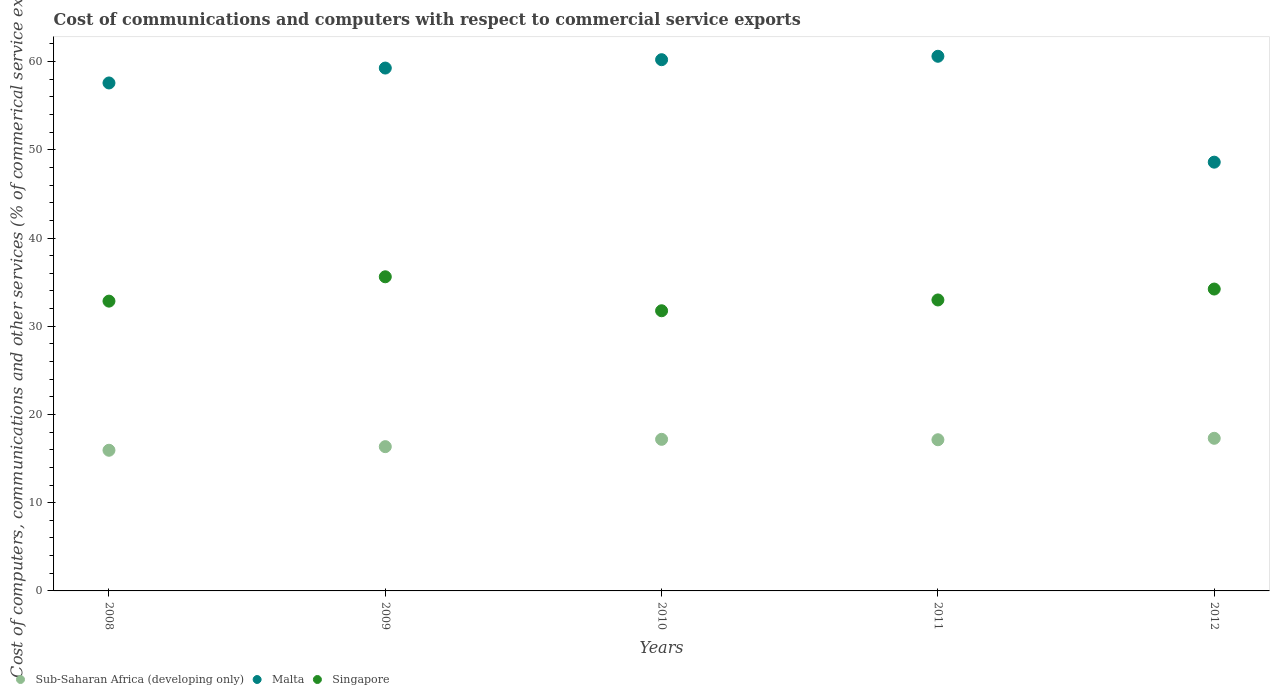What is the cost of communications and computers in Malta in 2010?
Your answer should be very brief. 60.22. Across all years, what is the maximum cost of communications and computers in Singapore?
Give a very brief answer. 35.61. Across all years, what is the minimum cost of communications and computers in Singapore?
Keep it short and to the point. 31.76. In which year was the cost of communications and computers in Malta minimum?
Give a very brief answer. 2012. What is the total cost of communications and computers in Sub-Saharan Africa (developing only) in the graph?
Ensure brevity in your answer.  83.92. What is the difference between the cost of communications and computers in Sub-Saharan Africa (developing only) in 2011 and that in 2012?
Provide a succinct answer. -0.16. What is the difference between the cost of communications and computers in Malta in 2011 and the cost of communications and computers in Singapore in 2009?
Give a very brief answer. 25. What is the average cost of communications and computers in Sub-Saharan Africa (developing only) per year?
Make the answer very short. 16.78. In the year 2012, what is the difference between the cost of communications and computers in Sub-Saharan Africa (developing only) and cost of communications and computers in Singapore?
Offer a very short reply. -16.92. What is the ratio of the cost of communications and computers in Malta in 2009 to that in 2012?
Your answer should be very brief. 1.22. Is the difference between the cost of communications and computers in Sub-Saharan Africa (developing only) in 2009 and 2011 greater than the difference between the cost of communications and computers in Singapore in 2009 and 2011?
Your answer should be compact. No. What is the difference between the highest and the second highest cost of communications and computers in Singapore?
Your response must be concise. 1.39. What is the difference between the highest and the lowest cost of communications and computers in Sub-Saharan Africa (developing only)?
Offer a terse response. 1.36. In how many years, is the cost of communications and computers in Singapore greater than the average cost of communications and computers in Singapore taken over all years?
Ensure brevity in your answer.  2. Does the cost of communications and computers in Singapore monotonically increase over the years?
Give a very brief answer. No. Is the cost of communications and computers in Singapore strictly less than the cost of communications and computers in Sub-Saharan Africa (developing only) over the years?
Your answer should be compact. No. How many dotlines are there?
Provide a succinct answer. 3. How many years are there in the graph?
Your answer should be very brief. 5. How many legend labels are there?
Provide a short and direct response. 3. What is the title of the graph?
Offer a terse response. Cost of communications and computers with respect to commercial service exports. Does "Bahamas" appear as one of the legend labels in the graph?
Your answer should be very brief. No. What is the label or title of the X-axis?
Give a very brief answer. Years. What is the label or title of the Y-axis?
Your answer should be very brief. Cost of computers, communications and other services (% of commerical service exports). What is the Cost of computers, communications and other services (% of commerical service exports) in Sub-Saharan Africa (developing only) in 2008?
Offer a very short reply. 15.95. What is the Cost of computers, communications and other services (% of commerical service exports) of Malta in 2008?
Provide a short and direct response. 57.58. What is the Cost of computers, communications and other services (% of commerical service exports) in Singapore in 2008?
Provide a succinct answer. 32.85. What is the Cost of computers, communications and other services (% of commerical service exports) in Sub-Saharan Africa (developing only) in 2009?
Provide a succinct answer. 16.35. What is the Cost of computers, communications and other services (% of commerical service exports) in Malta in 2009?
Provide a succinct answer. 59.27. What is the Cost of computers, communications and other services (% of commerical service exports) of Singapore in 2009?
Your answer should be compact. 35.61. What is the Cost of computers, communications and other services (% of commerical service exports) in Sub-Saharan Africa (developing only) in 2010?
Ensure brevity in your answer.  17.18. What is the Cost of computers, communications and other services (% of commerical service exports) of Malta in 2010?
Your response must be concise. 60.22. What is the Cost of computers, communications and other services (% of commerical service exports) in Singapore in 2010?
Your answer should be very brief. 31.76. What is the Cost of computers, communications and other services (% of commerical service exports) in Sub-Saharan Africa (developing only) in 2011?
Give a very brief answer. 17.14. What is the Cost of computers, communications and other services (% of commerical service exports) of Malta in 2011?
Your answer should be compact. 60.61. What is the Cost of computers, communications and other services (% of commerical service exports) in Singapore in 2011?
Your answer should be very brief. 32.98. What is the Cost of computers, communications and other services (% of commerical service exports) in Sub-Saharan Africa (developing only) in 2012?
Provide a short and direct response. 17.3. What is the Cost of computers, communications and other services (% of commerical service exports) of Malta in 2012?
Ensure brevity in your answer.  48.6. What is the Cost of computers, communications and other services (% of commerical service exports) in Singapore in 2012?
Your answer should be compact. 34.22. Across all years, what is the maximum Cost of computers, communications and other services (% of commerical service exports) of Sub-Saharan Africa (developing only)?
Give a very brief answer. 17.3. Across all years, what is the maximum Cost of computers, communications and other services (% of commerical service exports) in Malta?
Your answer should be compact. 60.61. Across all years, what is the maximum Cost of computers, communications and other services (% of commerical service exports) in Singapore?
Make the answer very short. 35.61. Across all years, what is the minimum Cost of computers, communications and other services (% of commerical service exports) of Sub-Saharan Africa (developing only)?
Give a very brief answer. 15.95. Across all years, what is the minimum Cost of computers, communications and other services (% of commerical service exports) in Malta?
Offer a very short reply. 48.6. Across all years, what is the minimum Cost of computers, communications and other services (% of commerical service exports) of Singapore?
Keep it short and to the point. 31.76. What is the total Cost of computers, communications and other services (% of commerical service exports) in Sub-Saharan Africa (developing only) in the graph?
Offer a very short reply. 83.92. What is the total Cost of computers, communications and other services (% of commerical service exports) in Malta in the graph?
Provide a short and direct response. 286.29. What is the total Cost of computers, communications and other services (% of commerical service exports) in Singapore in the graph?
Your response must be concise. 167.43. What is the difference between the Cost of computers, communications and other services (% of commerical service exports) of Sub-Saharan Africa (developing only) in 2008 and that in 2009?
Provide a succinct answer. -0.41. What is the difference between the Cost of computers, communications and other services (% of commerical service exports) in Malta in 2008 and that in 2009?
Your answer should be compact. -1.69. What is the difference between the Cost of computers, communications and other services (% of commerical service exports) of Singapore in 2008 and that in 2009?
Offer a very short reply. -2.76. What is the difference between the Cost of computers, communications and other services (% of commerical service exports) of Sub-Saharan Africa (developing only) in 2008 and that in 2010?
Your answer should be compact. -1.24. What is the difference between the Cost of computers, communications and other services (% of commerical service exports) in Malta in 2008 and that in 2010?
Provide a succinct answer. -2.64. What is the difference between the Cost of computers, communications and other services (% of commerical service exports) in Singapore in 2008 and that in 2010?
Give a very brief answer. 1.09. What is the difference between the Cost of computers, communications and other services (% of commerical service exports) in Sub-Saharan Africa (developing only) in 2008 and that in 2011?
Keep it short and to the point. -1.19. What is the difference between the Cost of computers, communications and other services (% of commerical service exports) of Malta in 2008 and that in 2011?
Offer a very short reply. -3.03. What is the difference between the Cost of computers, communications and other services (% of commerical service exports) of Singapore in 2008 and that in 2011?
Your answer should be compact. -0.13. What is the difference between the Cost of computers, communications and other services (% of commerical service exports) of Sub-Saharan Africa (developing only) in 2008 and that in 2012?
Make the answer very short. -1.36. What is the difference between the Cost of computers, communications and other services (% of commerical service exports) of Malta in 2008 and that in 2012?
Keep it short and to the point. 8.98. What is the difference between the Cost of computers, communications and other services (% of commerical service exports) in Singapore in 2008 and that in 2012?
Your answer should be very brief. -1.37. What is the difference between the Cost of computers, communications and other services (% of commerical service exports) in Sub-Saharan Africa (developing only) in 2009 and that in 2010?
Give a very brief answer. -0.83. What is the difference between the Cost of computers, communications and other services (% of commerical service exports) in Malta in 2009 and that in 2010?
Provide a short and direct response. -0.95. What is the difference between the Cost of computers, communications and other services (% of commerical service exports) in Singapore in 2009 and that in 2010?
Make the answer very short. 3.85. What is the difference between the Cost of computers, communications and other services (% of commerical service exports) of Sub-Saharan Africa (developing only) in 2009 and that in 2011?
Your response must be concise. -0.78. What is the difference between the Cost of computers, communications and other services (% of commerical service exports) of Malta in 2009 and that in 2011?
Offer a terse response. -1.34. What is the difference between the Cost of computers, communications and other services (% of commerical service exports) in Singapore in 2009 and that in 2011?
Offer a very short reply. 2.63. What is the difference between the Cost of computers, communications and other services (% of commerical service exports) in Sub-Saharan Africa (developing only) in 2009 and that in 2012?
Ensure brevity in your answer.  -0.95. What is the difference between the Cost of computers, communications and other services (% of commerical service exports) of Malta in 2009 and that in 2012?
Offer a terse response. 10.67. What is the difference between the Cost of computers, communications and other services (% of commerical service exports) in Singapore in 2009 and that in 2012?
Provide a short and direct response. 1.39. What is the difference between the Cost of computers, communications and other services (% of commerical service exports) of Sub-Saharan Africa (developing only) in 2010 and that in 2011?
Give a very brief answer. 0.05. What is the difference between the Cost of computers, communications and other services (% of commerical service exports) in Malta in 2010 and that in 2011?
Your response must be concise. -0.39. What is the difference between the Cost of computers, communications and other services (% of commerical service exports) in Singapore in 2010 and that in 2011?
Your answer should be compact. -1.22. What is the difference between the Cost of computers, communications and other services (% of commerical service exports) in Sub-Saharan Africa (developing only) in 2010 and that in 2012?
Your answer should be compact. -0.12. What is the difference between the Cost of computers, communications and other services (% of commerical service exports) of Malta in 2010 and that in 2012?
Your answer should be very brief. 11.62. What is the difference between the Cost of computers, communications and other services (% of commerical service exports) in Singapore in 2010 and that in 2012?
Keep it short and to the point. -2.46. What is the difference between the Cost of computers, communications and other services (% of commerical service exports) of Sub-Saharan Africa (developing only) in 2011 and that in 2012?
Your answer should be very brief. -0.16. What is the difference between the Cost of computers, communications and other services (% of commerical service exports) in Malta in 2011 and that in 2012?
Your response must be concise. 12. What is the difference between the Cost of computers, communications and other services (% of commerical service exports) of Singapore in 2011 and that in 2012?
Keep it short and to the point. -1.24. What is the difference between the Cost of computers, communications and other services (% of commerical service exports) in Sub-Saharan Africa (developing only) in 2008 and the Cost of computers, communications and other services (% of commerical service exports) in Malta in 2009?
Your answer should be compact. -43.33. What is the difference between the Cost of computers, communications and other services (% of commerical service exports) in Sub-Saharan Africa (developing only) in 2008 and the Cost of computers, communications and other services (% of commerical service exports) in Singapore in 2009?
Your answer should be compact. -19.66. What is the difference between the Cost of computers, communications and other services (% of commerical service exports) in Malta in 2008 and the Cost of computers, communications and other services (% of commerical service exports) in Singapore in 2009?
Your answer should be compact. 21.97. What is the difference between the Cost of computers, communications and other services (% of commerical service exports) of Sub-Saharan Africa (developing only) in 2008 and the Cost of computers, communications and other services (% of commerical service exports) of Malta in 2010?
Offer a very short reply. -44.27. What is the difference between the Cost of computers, communications and other services (% of commerical service exports) in Sub-Saharan Africa (developing only) in 2008 and the Cost of computers, communications and other services (% of commerical service exports) in Singapore in 2010?
Your answer should be compact. -15.81. What is the difference between the Cost of computers, communications and other services (% of commerical service exports) of Malta in 2008 and the Cost of computers, communications and other services (% of commerical service exports) of Singapore in 2010?
Give a very brief answer. 25.82. What is the difference between the Cost of computers, communications and other services (% of commerical service exports) of Sub-Saharan Africa (developing only) in 2008 and the Cost of computers, communications and other services (% of commerical service exports) of Malta in 2011?
Provide a short and direct response. -44.66. What is the difference between the Cost of computers, communications and other services (% of commerical service exports) in Sub-Saharan Africa (developing only) in 2008 and the Cost of computers, communications and other services (% of commerical service exports) in Singapore in 2011?
Ensure brevity in your answer.  -17.04. What is the difference between the Cost of computers, communications and other services (% of commerical service exports) in Malta in 2008 and the Cost of computers, communications and other services (% of commerical service exports) in Singapore in 2011?
Ensure brevity in your answer.  24.6. What is the difference between the Cost of computers, communications and other services (% of commerical service exports) in Sub-Saharan Africa (developing only) in 2008 and the Cost of computers, communications and other services (% of commerical service exports) in Malta in 2012?
Offer a very short reply. -32.66. What is the difference between the Cost of computers, communications and other services (% of commerical service exports) in Sub-Saharan Africa (developing only) in 2008 and the Cost of computers, communications and other services (% of commerical service exports) in Singapore in 2012?
Provide a succinct answer. -18.27. What is the difference between the Cost of computers, communications and other services (% of commerical service exports) of Malta in 2008 and the Cost of computers, communications and other services (% of commerical service exports) of Singapore in 2012?
Your response must be concise. 23.36. What is the difference between the Cost of computers, communications and other services (% of commerical service exports) in Sub-Saharan Africa (developing only) in 2009 and the Cost of computers, communications and other services (% of commerical service exports) in Malta in 2010?
Give a very brief answer. -43.87. What is the difference between the Cost of computers, communications and other services (% of commerical service exports) of Sub-Saharan Africa (developing only) in 2009 and the Cost of computers, communications and other services (% of commerical service exports) of Singapore in 2010?
Provide a succinct answer. -15.4. What is the difference between the Cost of computers, communications and other services (% of commerical service exports) in Malta in 2009 and the Cost of computers, communications and other services (% of commerical service exports) in Singapore in 2010?
Your answer should be compact. 27.51. What is the difference between the Cost of computers, communications and other services (% of commerical service exports) in Sub-Saharan Africa (developing only) in 2009 and the Cost of computers, communications and other services (% of commerical service exports) in Malta in 2011?
Provide a short and direct response. -44.25. What is the difference between the Cost of computers, communications and other services (% of commerical service exports) in Sub-Saharan Africa (developing only) in 2009 and the Cost of computers, communications and other services (% of commerical service exports) in Singapore in 2011?
Ensure brevity in your answer.  -16.63. What is the difference between the Cost of computers, communications and other services (% of commerical service exports) of Malta in 2009 and the Cost of computers, communications and other services (% of commerical service exports) of Singapore in 2011?
Give a very brief answer. 26.29. What is the difference between the Cost of computers, communications and other services (% of commerical service exports) in Sub-Saharan Africa (developing only) in 2009 and the Cost of computers, communications and other services (% of commerical service exports) in Malta in 2012?
Keep it short and to the point. -32.25. What is the difference between the Cost of computers, communications and other services (% of commerical service exports) in Sub-Saharan Africa (developing only) in 2009 and the Cost of computers, communications and other services (% of commerical service exports) in Singapore in 2012?
Your answer should be compact. -17.87. What is the difference between the Cost of computers, communications and other services (% of commerical service exports) in Malta in 2009 and the Cost of computers, communications and other services (% of commerical service exports) in Singapore in 2012?
Offer a terse response. 25.05. What is the difference between the Cost of computers, communications and other services (% of commerical service exports) in Sub-Saharan Africa (developing only) in 2010 and the Cost of computers, communications and other services (% of commerical service exports) in Malta in 2011?
Provide a succinct answer. -43.42. What is the difference between the Cost of computers, communications and other services (% of commerical service exports) of Sub-Saharan Africa (developing only) in 2010 and the Cost of computers, communications and other services (% of commerical service exports) of Singapore in 2011?
Make the answer very short. -15.8. What is the difference between the Cost of computers, communications and other services (% of commerical service exports) of Malta in 2010 and the Cost of computers, communications and other services (% of commerical service exports) of Singapore in 2011?
Make the answer very short. 27.24. What is the difference between the Cost of computers, communications and other services (% of commerical service exports) in Sub-Saharan Africa (developing only) in 2010 and the Cost of computers, communications and other services (% of commerical service exports) in Malta in 2012?
Your answer should be compact. -31.42. What is the difference between the Cost of computers, communications and other services (% of commerical service exports) in Sub-Saharan Africa (developing only) in 2010 and the Cost of computers, communications and other services (% of commerical service exports) in Singapore in 2012?
Give a very brief answer. -17.04. What is the difference between the Cost of computers, communications and other services (% of commerical service exports) in Sub-Saharan Africa (developing only) in 2011 and the Cost of computers, communications and other services (% of commerical service exports) in Malta in 2012?
Your response must be concise. -31.47. What is the difference between the Cost of computers, communications and other services (% of commerical service exports) of Sub-Saharan Africa (developing only) in 2011 and the Cost of computers, communications and other services (% of commerical service exports) of Singapore in 2012?
Your response must be concise. -17.08. What is the difference between the Cost of computers, communications and other services (% of commerical service exports) of Malta in 2011 and the Cost of computers, communications and other services (% of commerical service exports) of Singapore in 2012?
Ensure brevity in your answer.  26.39. What is the average Cost of computers, communications and other services (% of commerical service exports) in Sub-Saharan Africa (developing only) per year?
Offer a terse response. 16.78. What is the average Cost of computers, communications and other services (% of commerical service exports) of Malta per year?
Offer a terse response. 57.26. What is the average Cost of computers, communications and other services (% of commerical service exports) of Singapore per year?
Provide a short and direct response. 33.49. In the year 2008, what is the difference between the Cost of computers, communications and other services (% of commerical service exports) in Sub-Saharan Africa (developing only) and Cost of computers, communications and other services (% of commerical service exports) in Malta?
Offer a terse response. -41.64. In the year 2008, what is the difference between the Cost of computers, communications and other services (% of commerical service exports) of Sub-Saharan Africa (developing only) and Cost of computers, communications and other services (% of commerical service exports) of Singapore?
Provide a succinct answer. -16.9. In the year 2008, what is the difference between the Cost of computers, communications and other services (% of commerical service exports) of Malta and Cost of computers, communications and other services (% of commerical service exports) of Singapore?
Offer a terse response. 24.73. In the year 2009, what is the difference between the Cost of computers, communications and other services (% of commerical service exports) of Sub-Saharan Africa (developing only) and Cost of computers, communications and other services (% of commerical service exports) of Malta?
Offer a terse response. -42.92. In the year 2009, what is the difference between the Cost of computers, communications and other services (% of commerical service exports) in Sub-Saharan Africa (developing only) and Cost of computers, communications and other services (% of commerical service exports) in Singapore?
Provide a short and direct response. -19.26. In the year 2009, what is the difference between the Cost of computers, communications and other services (% of commerical service exports) in Malta and Cost of computers, communications and other services (% of commerical service exports) in Singapore?
Your response must be concise. 23.66. In the year 2010, what is the difference between the Cost of computers, communications and other services (% of commerical service exports) of Sub-Saharan Africa (developing only) and Cost of computers, communications and other services (% of commerical service exports) of Malta?
Your answer should be very brief. -43.04. In the year 2010, what is the difference between the Cost of computers, communications and other services (% of commerical service exports) of Sub-Saharan Africa (developing only) and Cost of computers, communications and other services (% of commerical service exports) of Singapore?
Your answer should be compact. -14.57. In the year 2010, what is the difference between the Cost of computers, communications and other services (% of commerical service exports) of Malta and Cost of computers, communications and other services (% of commerical service exports) of Singapore?
Offer a very short reply. 28.46. In the year 2011, what is the difference between the Cost of computers, communications and other services (% of commerical service exports) in Sub-Saharan Africa (developing only) and Cost of computers, communications and other services (% of commerical service exports) in Malta?
Your answer should be very brief. -43.47. In the year 2011, what is the difference between the Cost of computers, communications and other services (% of commerical service exports) in Sub-Saharan Africa (developing only) and Cost of computers, communications and other services (% of commerical service exports) in Singapore?
Ensure brevity in your answer.  -15.85. In the year 2011, what is the difference between the Cost of computers, communications and other services (% of commerical service exports) of Malta and Cost of computers, communications and other services (% of commerical service exports) of Singapore?
Offer a very short reply. 27.62. In the year 2012, what is the difference between the Cost of computers, communications and other services (% of commerical service exports) of Sub-Saharan Africa (developing only) and Cost of computers, communications and other services (% of commerical service exports) of Malta?
Make the answer very short. -31.3. In the year 2012, what is the difference between the Cost of computers, communications and other services (% of commerical service exports) in Sub-Saharan Africa (developing only) and Cost of computers, communications and other services (% of commerical service exports) in Singapore?
Offer a very short reply. -16.92. In the year 2012, what is the difference between the Cost of computers, communications and other services (% of commerical service exports) in Malta and Cost of computers, communications and other services (% of commerical service exports) in Singapore?
Offer a very short reply. 14.38. What is the ratio of the Cost of computers, communications and other services (% of commerical service exports) in Malta in 2008 to that in 2009?
Offer a terse response. 0.97. What is the ratio of the Cost of computers, communications and other services (% of commerical service exports) of Singapore in 2008 to that in 2009?
Your answer should be very brief. 0.92. What is the ratio of the Cost of computers, communications and other services (% of commerical service exports) in Sub-Saharan Africa (developing only) in 2008 to that in 2010?
Ensure brevity in your answer.  0.93. What is the ratio of the Cost of computers, communications and other services (% of commerical service exports) in Malta in 2008 to that in 2010?
Your response must be concise. 0.96. What is the ratio of the Cost of computers, communications and other services (% of commerical service exports) in Singapore in 2008 to that in 2010?
Your response must be concise. 1.03. What is the ratio of the Cost of computers, communications and other services (% of commerical service exports) in Sub-Saharan Africa (developing only) in 2008 to that in 2011?
Provide a short and direct response. 0.93. What is the ratio of the Cost of computers, communications and other services (% of commerical service exports) in Malta in 2008 to that in 2011?
Your answer should be compact. 0.95. What is the ratio of the Cost of computers, communications and other services (% of commerical service exports) of Singapore in 2008 to that in 2011?
Keep it short and to the point. 1. What is the ratio of the Cost of computers, communications and other services (% of commerical service exports) in Sub-Saharan Africa (developing only) in 2008 to that in 2012?
Ensure brevity in your answer.  0.92. What is the ratio of the Cost of computers, communications and other services (% of commerical service exports) in Malta in 2008 to that in 2012?
Provide a short and direct response. 1.18. What is the ratio of the Cost of computers, communications and other services (% of commerical service exports) of Singapore in 2008 to that in 2012?
Your answer should be compact. 0.96. What is the ratio of the Cost of computers, communications and other services (% of commerical service exports) in Sub-Saharan Africa (developing only) in 2009 to that in 2010?
Offer a very short reply. 0.95. What is the ratio of the Cost of computers, communications and other services (% of commerical service exports) of Malta in 2009 to that in 2010?
Make the answer very short. 0.98. What is the ratio of the Cost of computers, communications and other services (% of commerical service exports) in Singapore in 2009 to that in 2010?
Ensure brevity in your answer.  1.12. What is the ratio of the Cost of computers, communications and other services (% of commerical service exports) in Sub-Saharan Africa (developing only) in 2009 to that in 2011?
Give a very brief answer. 0.95. What is the ratio of the Cost of computers, communications and other services (% of commerical service exports) in Malta in 2009 to that in 2011?
Keep it short and to the point. 0.98. What is the ratio of the Cost of computers, communications and other services (% of commerical service exports) of Singapore in 2009 to that in 2011?
Keep it short and to the point. 1.08. What is the ratio of the Cost of computers, communications and other services (% of commerical service exports) in Sub-Saharan Africa (developing only) in 2009 to that in 2012?
Provide a short and direct response. 0.95. What is the ratio of the Cost of computers, communications and other services (% of commerical service exports) of Malta in 2009 to that in 2012?
Ensure brevity in your answer.  1.22. What is the ratio of the Cost of computers, communications and other services (% of commerical service exports) of Singapore in 2009 to that in 2012?
Ensure brevity in your answer.  1.04. What is the ratio of the Cost of computers, communications and other services (% of commerical service exports) of Sub-Saharan Africa (developing only) in 2010 to that in 2011?
Provide a short and direct response. 1. What is the ratio of the Cost of computers, communications and other services (% of commerical service exports) of Singapore in 2010 to that in 2011?
Provide a short and direct response. 0.96. What is the ratio of the Cost of computers, communications and other services (% of commerical service exports) in Sub-Saharan Africa (developing only) in 2010 to that in 2012?
Your response must be concise. 0.99. What is the ratio of the Cost of computers, communications and other services (% of commerical service exports) in Malta in 2010 to that in 2012?
Ensure brevity in your answer.  1.24. What is the ratio of the Cost of computers, communications and other services (% of commerical service exports) in Singapore in 2010 to that in 2012?
Offer a terse response. 0.93. What is the ratio of the Cost of computers, communications and other services (% of commerical service exports) in Malta in 2011 to that in 2012?
Give a very brief answer. 1.25. What is the ratio of the Cost of computers, communications and other services (% of commerical service exports) in Singapore in 2011 to that in 2012?
Provide a short and direct response. 0.96. What is the difference between the highest and the second highest Cost of computers, communications and other services (% of commerical service exports) of Sub-Saharan Africa (developing only)?
Your answer should be very brief. 0.12. What is the difference between the highest and the second highest Cost of computers, communications and other services (% of commerical service exports) of Malta?
Ensure brevity in your answer.  0.39. What is the difference between the highest and the second highest Cost of computers, communications and other services (% of commerical service exports) in Singapore?
Your answer should be very brief. 1.39. What is the difference between the highest and the lowest Cost of computers, communications and other services (% of commerical service exports) in Sub-Saharan Africa (developing only)?
Provide a succinct answer. 1.36. What is the difference between the highest and the lowest Cost of computers, communications and other services (% of commerical service exports) of Malta?
Offer a very short reply. 12. What is the difference between the highest and the lowest Cost of computers, communications and other services (% of commerical service exports) in Singapore?
Your response must be concise. 3.85. 